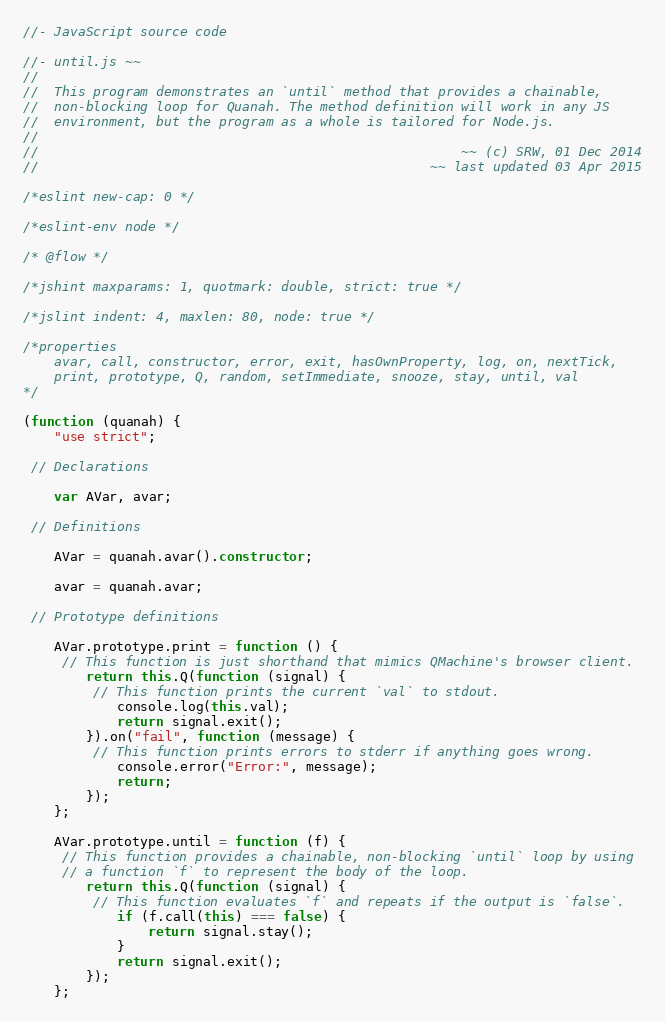<code> <loc_0><loc_0><loc_500><loc_500><_JavaScript_>//- JavaScript source code

//- until.js ~~
//
//  This program demonstrates an `until` method that provides a chainable,
//  non-blocking loop for Quanah. The method definition will work in any JS
//  environment, but the program as a whole is tailored for Node.js.
//
//                                                      ~~ (c) SRW, 01 Dec 2014
//                                                  ~~ last updated 03 Apr 2015

/*eslint new-cap: 0 */

/*eslint-env node */

/* @flow */

/*jshint maxparams: 1, quotmark: double, strict: true */

/*jslint indent: 4, maxlen: 80, node: true */

/*properties
    avar, call, constructor, error, exit, hasOwnProperty, log, on, nextTick,
    print, prototype, Q, random, setImmediate, snooze, stay, until, val
*/

(function (quanah) {
    "use strict";

 // Declarations

    var AVar, avar;

 // Definitions

    AVar = quanah.avar().constructor;

    avar = quanah.avar;

 // Prototype definitions

    AVar.prototype.print = function () {
     // This function is just shorthand that mimics QMachine's browser client.
        return this.Q(function (signal) {
         // This function prints the current `val` to stdout.
            console.log(this.val);
            return signal.exit();
        }).on("fail", function (message) {
         // This function prints errors to stderr if anything goes wrong.
            console.error("Error:", message);
            return;
        });
    };

    AVar.prototype.until = function (f) {
     // This function provides a chainable, non-blocking `until` loop by using
     // a function `f` to represent the body of the loop.
        return this.Q(function (signal) {
         // This function evaluates `f` and repeats if the output is `false`.
            if (f.call(this) === false) {
                return signal.stay();
            }
            return signal.exit();
        });
    };
</code> 